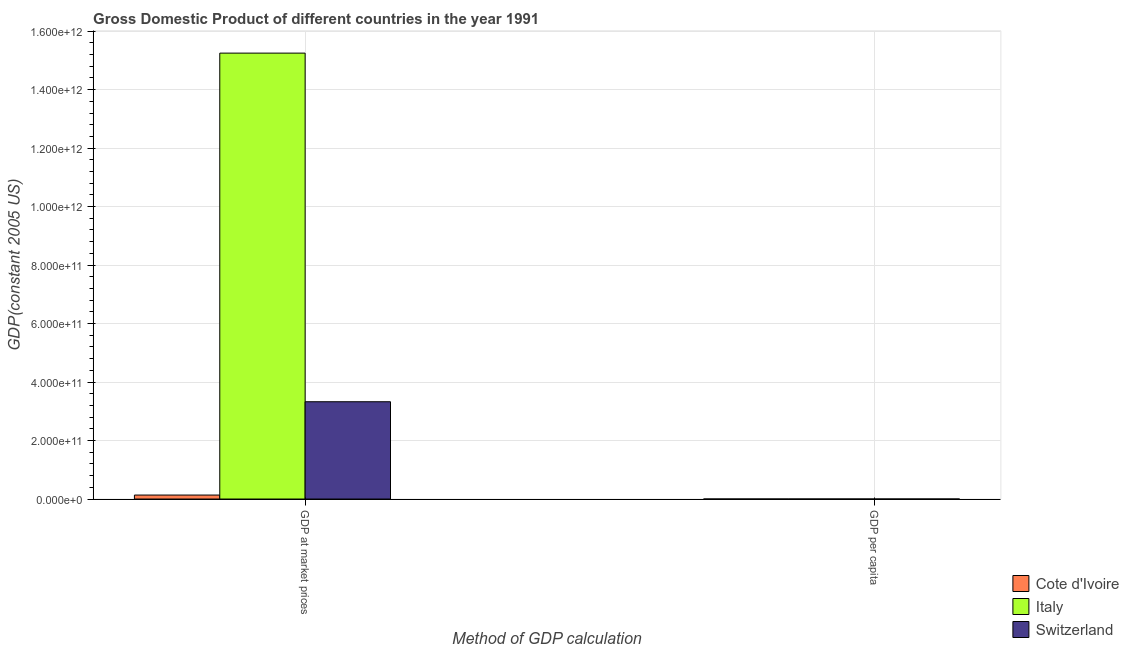Are the number of bars per tick equal to the number of legend labels?
Your answer should be very brief. Yes. Are the number of bars on each tick of the X-axis equal?
Your answer should be very brief. Yes. How many bars are there on the 2nd tick from the left?
Provide a succinct answer. 3. How many bars are there on the 2nd tick from the right?
Your answer should be compact. 3. What is the label of the 2nd group of bars from the left?
Your answer should be very brief. GDP per capita. What is the gdp at market prices in Italy?
Your answer should be compact. 1.52e+12. Across all countries, what is the maximum gdp per capita?
Your response must be concise. 4.89e+04. Across all countries, what is the minimum gdp per capita?
Provide a short and direct response. 1080.47. In which country was the gdp at market prices minimum?
Your response must be concise. Cote d'Ivoire. What is the total gdp at market prices in the graph?
Make the answer very short. 1.87e+12. What is the difference between the gdp per capita in Switzerland and that in Italy?
Your answer should be very brief. 2.21e+04. What is the difference between the gdp at market prices in Italy and the gdp per capita in Switzerland?
Keep it short and to the point. 1.52e+12. What is the average gdp at market prices per country?
Ensure brevity in your answer.  6.24e+11. What is the difference between the gdp per capita and gdp at market prices in Cote d'Ivoire?
Your answer should be compact. -1.36e+1. What is the ratio of the gdp per capita in Italy to that in Cote d'Ivoire?
Give a very brief answer. 24.86. In how many countries, is the gdp per capita greater than the average gdp per capita taken over all countries?
Ensure brevity in your answer.  2. What does the 1st bar from the left in GDP at market prices represents?
Offer a very short reply. Cote d'Ivoire. What does the 1st bar from the right in GDP at market prices represents?
Keep it short and to the point. Switzerland. How many bars are there?
Give a very brief answer. 6. Are all the bars in the graph horizontal?
Provide a succinct answer. No. How many countries are there in the graph?
Give a very brief answer. 3. What is the difference between two consecutive major ticks on the Y-axis?
Your answer should be compact. 2.00e+11. Does the graph contain grids?
Ensure brevity in your answer.  Yes. How many legend labels are there?
Offer a very short reply. 3. What is the title of the graph?
Provide a succinct answer. Gross Domestic Product of different countries in the year 1991. What is the label or title of the X-axis?
Give a very brief answer. Method of GDP calculation. What is the label or title of the Y-axis?
Ensure brevity in your answer.  GDP(constant 2005 US). What is the GDP(constant 2005 US) in Cote d'Ivoire in GDP at market prices?
Make the answer very short. 1.36e+1. What is the GDP(constant 2005 US) in Italy in GDP at market prices?
Your answer should be very brief. 1.52e+12. What is the GDP(constant 2005 US) of Switzerland in GDP at market prices?
Keep it short and to the point. 3.33e+11. What is the GDP(constant 2005 US) of Cote d'Ivoire in GDP per capita?
Provide a short and direct response. 1080.47. What is the GDP(constant 2005 US) in Italy in GDP per capita?
Provide a short and direct response. 2.69e+04. What is the GDP(constant 2005 US) in Switzerland in GDP per capita?
Offer a very short reply. 4.89e+04. Across all Method of GDP calculation, what is the maximum GDP(constant 2005 US) in Cote d'Ivoire?
Offer a very short reply. 1.36e+1. Across all Method of GDP calculation, what is the maximum GDP(constant 2005 US) in Italy?
Ensure brevity in your answer.  1.52e+12. Across all Method of GDP calculation, what is the maximum GDP(constant 2005 US) in Switzerland?
Ensure brevity in your answer.  3.33e+11. Across all Method of GDP calculation, what is the minimum GDP(constant 2005 US) of Cote d'Ivoire?
Your answer should be compact. 1080.47. Across all Method of GDP calculation, what is the minimum GDP(constant 2005 US) of Italy?
Make the answer very short. 2.69e+04. Across all Method of GDP calculation, what is the minimum GDP(constant 2005 US) of Switzerland?
Your response must be concise. 4.89e+04. What is the total GDP(constant 2005 US) in Cote d'Ivoire in the graph?
Keep it short and to the point. 1.36e+1. What is the total GDP(constant 2005 US) in Italy in the graph?
Give a very brief answer. 1.52e+12. What is the total GDP(constant 2005 US) of Switzerland in the graph?
Provide a succinct answer. 3.33e+11. What is the difference between the GDP(constant 2005 US) of Cote d'Ivoire in GDP at market prices and that in GDP per capita?
Make the answer very short. 1.36e+1. What is the difference between the GDP(constant 2005 US) of Italy in GDP at market prices and that in GDP per capita?
Offer a terse response. 1.52e+12. What is the difference between the GDP(constant 2005 US) in Switzerland in GDP at market prices and that in GDP per capita?
Your answer should be very brief. 3.33e+11. What is the difference between the GDP(constant 2005 US) of Cote d'Ivoire in GDP at market prices and the GDP(constant 2005 US) of Italy in GDP per capita?
Offer a very short reply. 1.36e+1. What is the difference between the GDP(constant 2005 US) of Cote d'Ivoire in GDP at market prices and the GDP(constant 2005 US) of Switzerland in GDP per capita?
Keep it short and to the point. 1.36e+1. What is the difference between the GDP(constant 2005 US) of Italy in GDP at market prices and the GDP(constant 2005 US) of Switzerland in GDP per capita?
Keep it short and to the point. 1.52e+12. What is the average GDP(constant 2005 US) in Cote d'Ivoire per Method of GDP calculation?
Provide a short and direct response. 6.81e+09. What is the average GDP(constant 2005 US) of Italy per Method of GDP calculation?
Provide a succinct answer. 7.62e+11. What is the average GDP(constant 2005 US) of Switzerland per Method of GDP calculation?
Offer a terse response. 1.66e+11. What is the difference between the GDP(constant 2005 US) in Cote d'Ivoire and GDP(constant 2005 US) in Italy in GDP at market prices?
Give a very brief answer. -1.51e+12. What is the difference between the GDP(constant 2005 US) in Cote d'Ivoire and GDP(constant 2005 US) in Switzerland in GDP at market prices?
Your answer should be compact. -3.19e+11. What is the difference between the GDP(constant 2005 US) in Italy and GDP(constant 2005 US) in Switzerland in GDP at market prices?
Your answer should be very brief. 1.19e+12. What is the difference between the GDP(constant 2005 US) of Cote d'Ivoire and GDP(constant 2005 US) of Italy in GDP per capita?
Your response must be concise. -2.58e+04. What is the difference between the GDP(constant 2005 US) of Cote d'Ivoire and GDP(constant 2005 US) of Switzerland in GDP per capita?
Your response must be concise. -4.78e+04. What is the difference between the GDP(constant 2005 US) of Italy and GDP(constant 2005 US) of Switzerland in GDP per capita?
Make the answer very short. -2.21e+04. What is the ratio of the GDP(constant 2005 US) in Cote d'Ivoire in GDP at market prices to that in GDP per capita?
Offer a very short reply. 1.26e+07. What is the ratio of the GDP(constant 2005 US) of Italy in GDP at market prices to that in GDP per capita?
Give a very brief answer. 5.68e+07. What is the ratio of the GDP(constant 2005 US) of Switzerland in GDP at market prices to that in GDP per capita?
Give a very brief answer. 6.80e+06. What is the difference between the highest and the second highest GDP(constant 2005 US) of Cote d'Ivoire?
Offer a terse response. 1.36e+1. What is the difference between the highest and the second highest GDP(constant 2005 US) of Italy?
Provide a short and direct response. 1.52e+12. What is the difference between the highest and the second highest GDP(constant 2005 US) in Switzerland?
Provide a short and direct response. 3.33e+11. What is the difference between the highest and the lowest GDP(constant 2005 US) in Cote d'Ivoire?
Keep it short and to the point. 1.36e+1. What is the difference between the highest and the lowest GDP(constant 2005 US) of Italy?
Keep it short and to the point. 1.52e+12. What is the difference between the highest and the lowest GDP(constant 2005 US) of Switzerland?
Provide a short and direct response. 3.33e+11. 